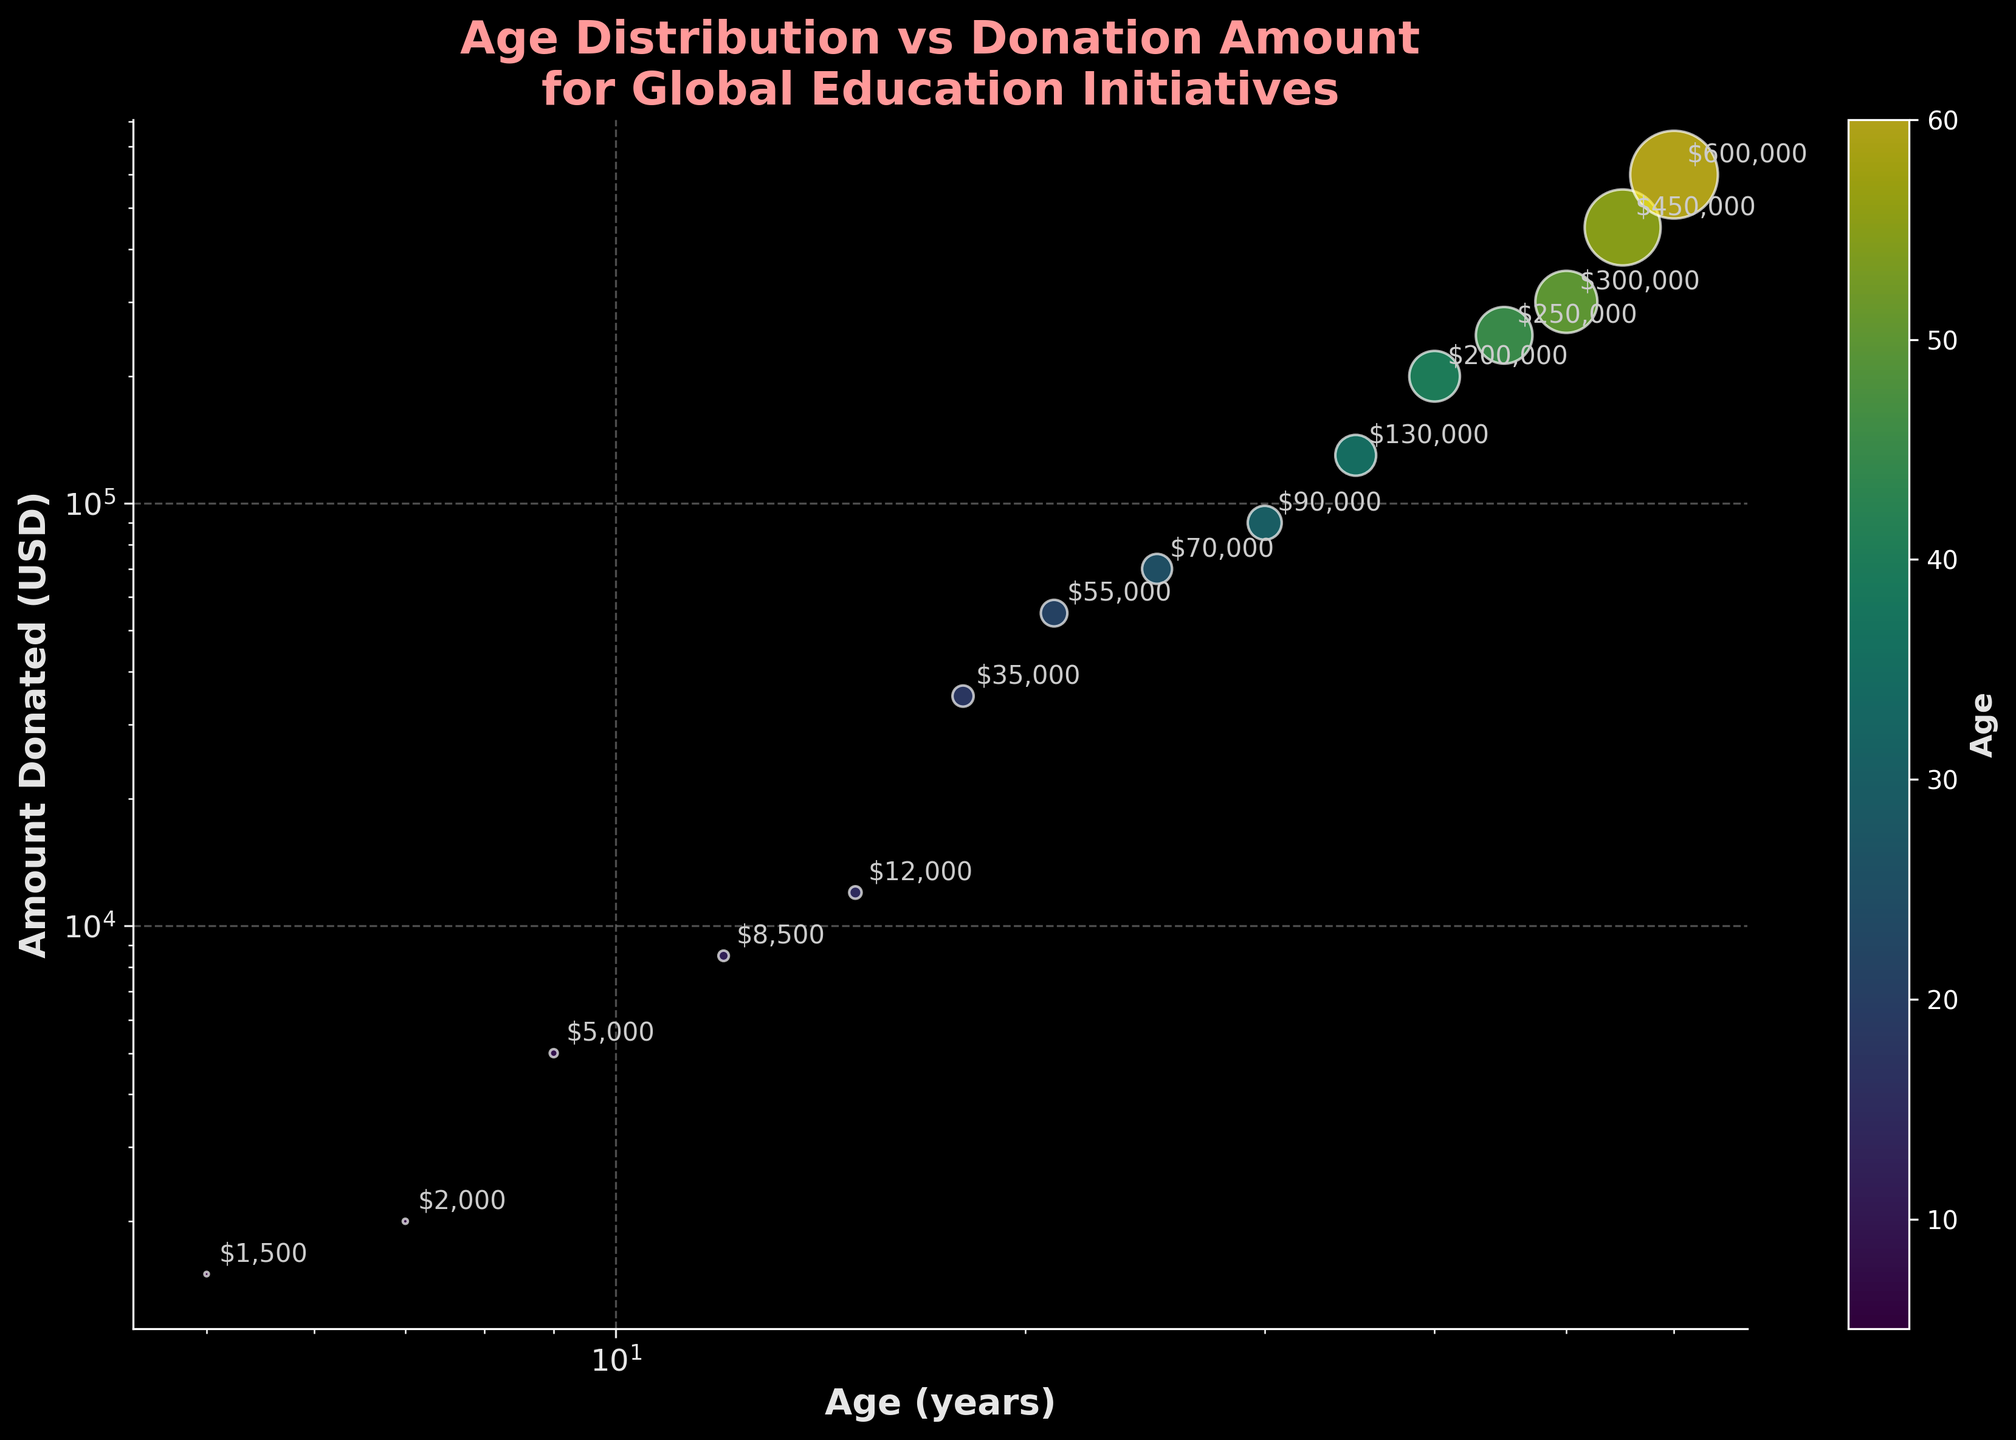What's the title of the plot? The title of the plot is displayed at the top of the figure. It is usually bold and colored differently for emphasis.
Answer: Age Distribution vs Donation Amount for Global Education Initiatives What are the axes labels? The axes labels describe the variables plotted on each axis. The x-axis label is typically below the horizontal axis, and the y-axis label is beside the vertical axis.
Answer: Age (years) and Amount Donated (USD) How many data points are there in the plot? Each scatter point in the plot represents a data point. You can count these points individually by looking at each plotted circle.
Answer: 15 What is the donation amount for the beneficiary aged 25? Locate the point where the age is 25 on the x-axis and look at the corresponding value on the y-axis. The annotation near the data point indicates the amount donated.
Answer: $70,000 At what age do donations surpass $100,000? Find the data points where the y-axis value exceeds $100,000 and identify the corresponding ages on the x-axis.
Answer: 35 years What is the median donation amount in the dataset? List all donation amounts, sort them in ascending order, and find the middle value. For 15 values, the median is the 8th value in the sorted list. Sorted List: 1500, 2000, 5000, 8500, 12000, 35000, 55000, 70000, 90000, 130000, 200000, 250000, 300000, 450000, 600000.
Answer: $70,000 Which age group gives the highest donation? Identify the highest value on the y-axis and then look at the corresponding age on the x-axis.
Answer: 60 years What is the ratio of the amount donated by the 50-year-old to the 30-year-old? Find the donation amounts for the 50-year-old and 30-year-old from the plot annotations and calculate their ratio: 300,000 / 90,000.
Answer: 3.33 By what factor does the donation amount increase from age 18 to age 45? Locate the donation amounts for the ages 18 and 45 from the plot annotations. Divide the latter by the former: 250,000 / 35,000.
Answer: 7.14 How does the donation amount change as the age of beneficiaries increases? Observe the trend of the plotted points as you move from younger to older ages along the x-axis. Note the increasing pattern in general.
Answer: Increases logarithmically 